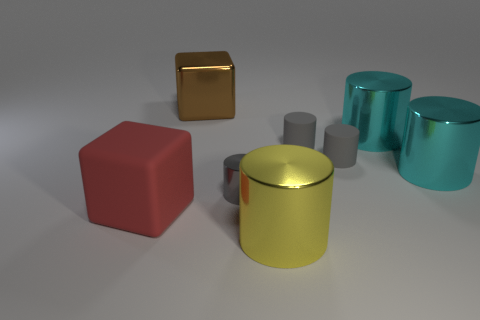What is the size of the cube that is to the left of the metallic cube?
Your answer should be compact. Large. What is the color of the metallic thing left of the tiny thing left of the metal cylinder that is in front of the gray metal cylinder?
Make the answer very short. Brown. The big metal object that is in front of the big red object that is in front of the brown object is what color?
Provide a succinct answer. Yellow. Is the number of big cyan metallic objects that are in front of the large yellow metallic thing greater than the number of big red rubber things on the right side of the brown shiny cube?
Offer a very short reply. No. Does the tiny cylinder that is on the left side of the big yellow shiny cylinder have the same material as the cube behind the gray shiny object?
Your response must be concise. Yes. There is a big red object; are there any red cubes in front of it?
Make the answer very short. No. What number of red objects are metal objects or rubber objects?
Provide a short and direct response. 1. Does the red block have the same material as the cylinder in front of the gray metal object?
Offer a very short reply. No. There is another rubber object that is the same shape as the brown object; what size is it?
Keep it short and to the point. Large. What is the large red cube made of?
Your answer should be compact. Rubber. 